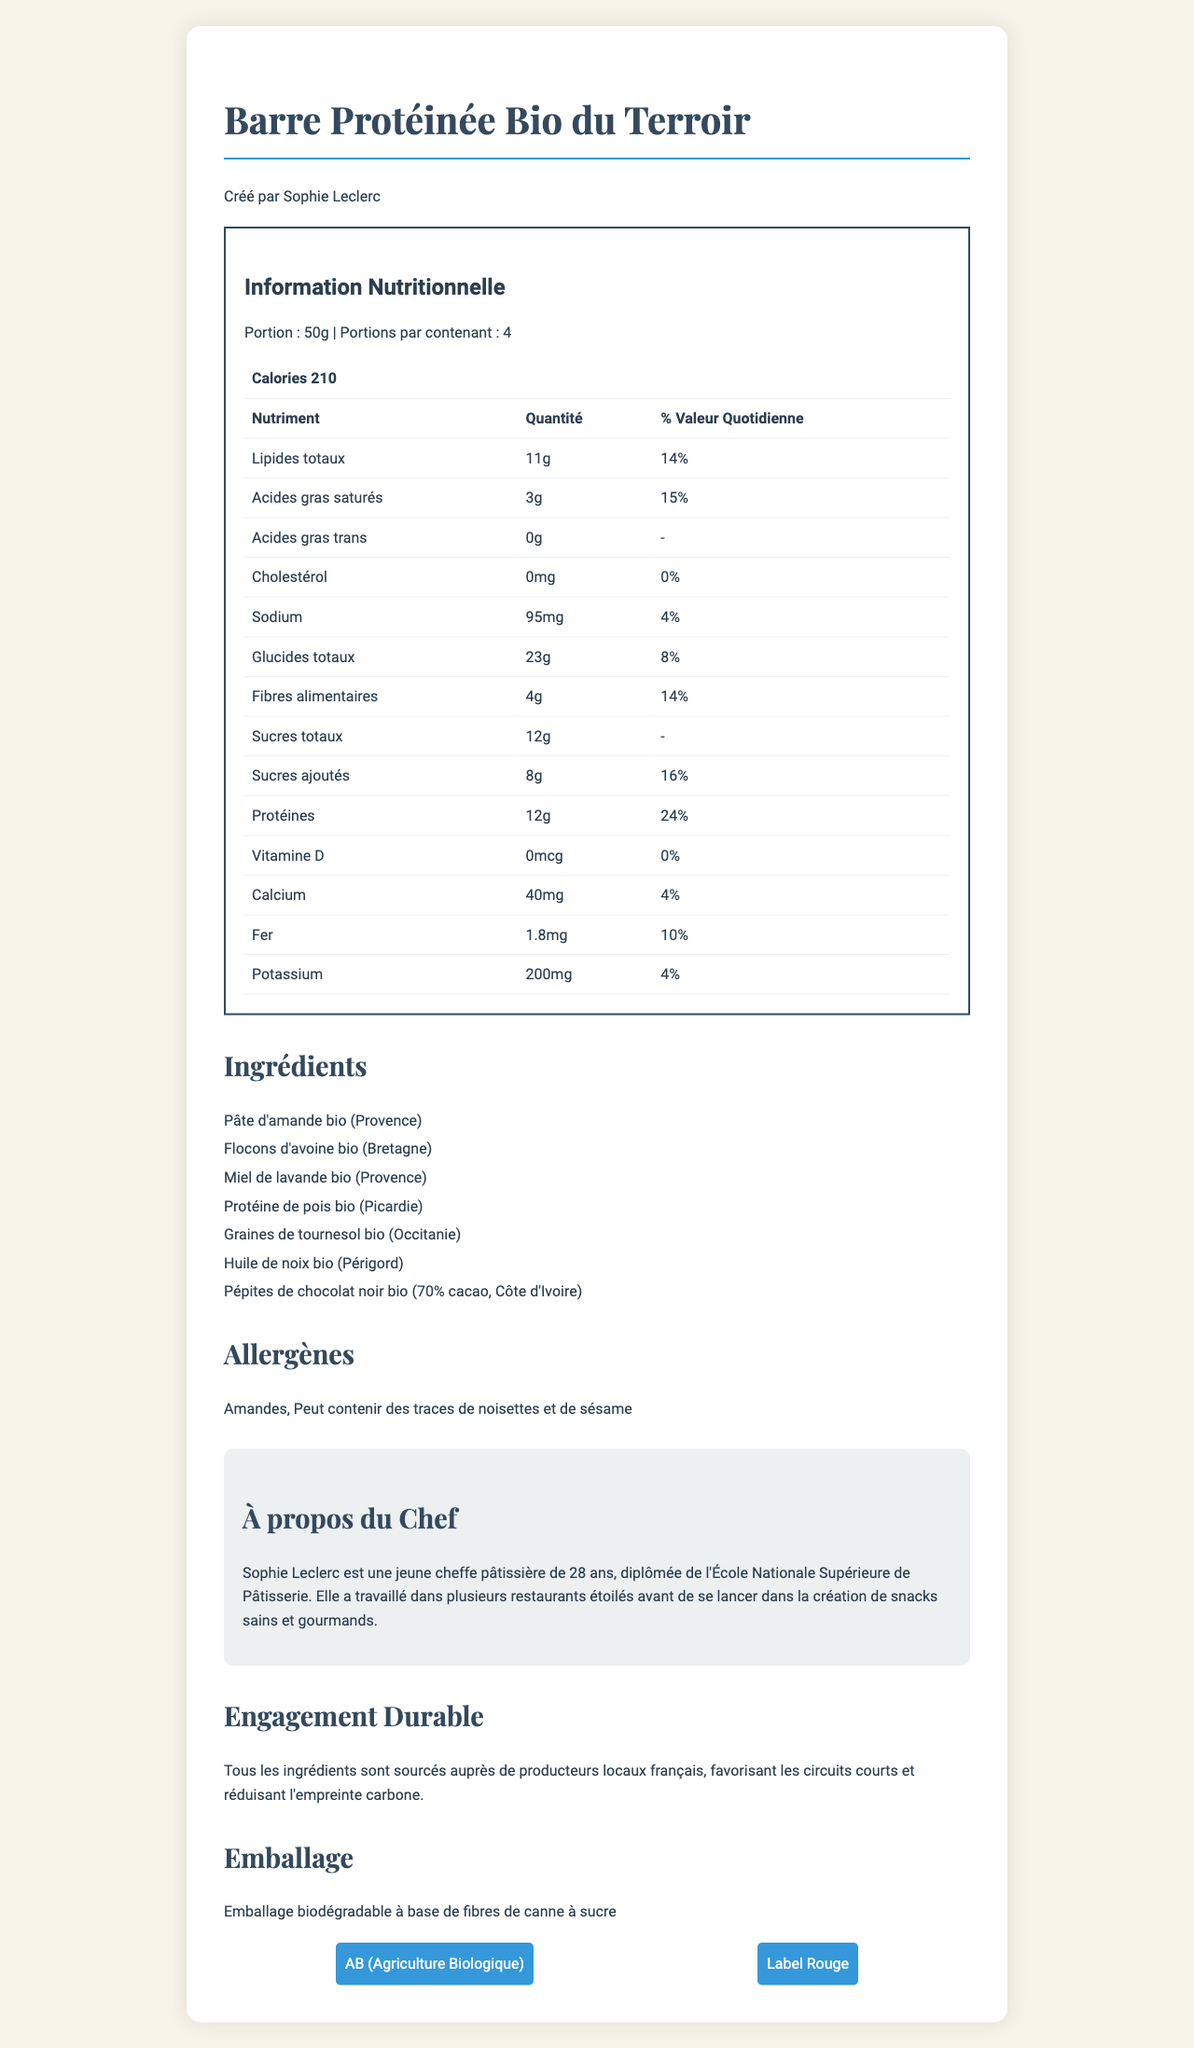what is the serving size of "Barre Protéinée Bio du Terroir"? According to the nutrition label, the serving size is mentioned as 50g.
Answer: 50g who created the "Barre Protéinée Bio du Terroir"? The document states that the product was created by Sophie Leclerc.
Answer: Sophie Leclerc how many servings are there per container? The document specifies that there are 4 servings per container.
Answer: 4 servings per container what is the calorie content per serving? The nutrition label lists the calorie content as 210 calories per serving.
Answer: 210 calories which region is the organic almond paste sourced from? The list of ingredients includes "Pâte d'amande bio (Provence)," indicating that the almond paste is sourced from Provence.
Answer: Provence What percentage of the daily value of protein is provided per serving? A. 14% B. 24% C. 16% The nutrition label indicates that the daily value of protein per serving is 24%.
Answer: B. 24% Which ingredient is not mentioned in the list? A. Pépites de chocolat noir B. Flocons d'avoine C. Protéine de soja The list of ingredients does not mention "Protéine de soja." It mentions "Protéine de pois" instead.
Answer: C. Protéine de soja Does the product contain any trans fat? The nutrition label states the amount of trans fat as 0g.
Answer: No is the packaging biodegradable? The document states that the packaging is biodegradable and made from sugarcane fibers.
Answer: Yes summarize the entire document. The main idea of the document is to highlight the nutritional, ingredient, and certification details of the organic protein bar, as well as its sustainable sourcing and packaging.
Answer: The document provides detailed information about an organic protein bar called "Barre Protéinée Bio du Terroir," created by French chef Sophie Leclerc. It includes the nutrition facts, serving size, and servings per container. The ingredients are locally sourced from different regions in France, and the product is certified organic (AB) and Label Rouge. The document also mentions the chef's background, sustainability practices, and the biodegradable packaging. What is the total fiber content per serving? The nutrition label lists the dietary fiber content as 4g per serving.
Answer: 4g What are the allergens listed in the document? The document mentions that the product contains almonds and may contain traces of hazelnuts and sesame.
Answer: Amandes, Peut contenir des traces de noisettes et de sésame What certifications does the product have? The document specifies that the product has two certifications: AB (Agriculture Biologique) and Label Rouge.
Answer: AB (Agriculture Biologique), Label Rouge What is the daily value percentage of iron provided per serving? According to the nutrition label, the daily value of iron per serving is 10%.
Answer: 10% Which ingredient is sourced from Picardie? A. Pépites de chocolat noir B. Huile de noix C. Protéine de pois The list of ingredients includes "Protéine de pois bio (Picardie)," indicating that the pea protein is sourced from Picardie.
Answer: C. Protéine de pois What inspired Sophie Leclerc to create this product? The document provides details about Sophie Leclerc's background but does not mention what specifically inspired her to create this product.
Answer: Not enough information Explain the sustainability note mentioned in the document. The document emphasizes environmental responsibility by stating that all ingredients are locally sourced within France, which supports short supply chains and lowers the carbon footprint.
Answer: All ingredients are sourced from local French producers, favoring short supply chains and reducing carbon footprint. 